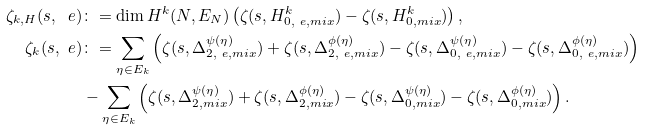Convert formula to latex. <formula><loc_0><loc_0><loc_500><loc_500>\zeta _ { k , H } ( s , \ e ) & \colon = \dim H ^ { k } ( N , E _ { N } ) \left ( \zeta ( s , H ^ { k } _ { 0 , \ e , { m i x } } ) - \zeta ( s , H ^ { k } _ { 0 , { m i x } } ) \right ) , \\ \zeta _ { k } ( s , \ e ) & \colon = \sum _ { \eta \in E _ { k } } \left ( \zeta ( s , \Delta ^ { \psi ( \eta ) } _ { 2 , \ e , m i x } ) + \zeta ( s , \Delta ^ { \phi ( \eta ) } _ { 2 , \ e , m i x } ) - \zeta ( s , \Delta ^ { \psi ( \eta ) } _ { 0 , \ e , m i x } ) - \zeta ( s , \Delta ^ { \phi ( \eta ) } _ { 0 , \ e , m i x } ) \right ) \\ & - \sum _ { \eta \in E _ { k } } \left ( \zeta ( s , \Delta ^ { \psi ( \eta ) } _ { 2 , m i x } ) + \zeta ( s , \Delta ^ { \phi ( \eta ) } _ { 2 , m i x } ) - \zeta ( s , \Delta ^ { \psi ( \eta ) } _ { 0 , m i x } ) - \zeta ( s , \Delta ^ { \phi ( \eta ) } _ { 0 , m i x } ) \right ) .</formula> 